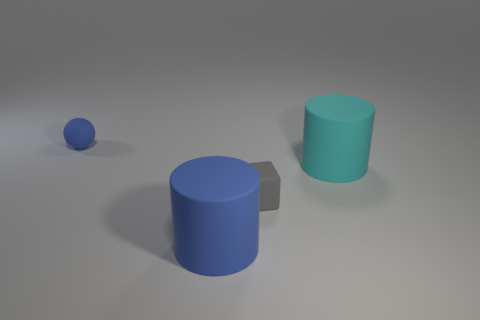Add 2 cubes. How many objects exist? 6 Subtract all balls. How many objects are left? 3 Subtract all big cyan rubber cylinders. Subtract all large green cylinders. How many objects are left? 3 Add 4 large cyan matte cylinders. How many large cyan matte cylinders are left? 5 Add 1 small brown matte blocks. How many small brown matte blocks exist? 1 Subtract 0 yellow balls. How many objects are left? 4 